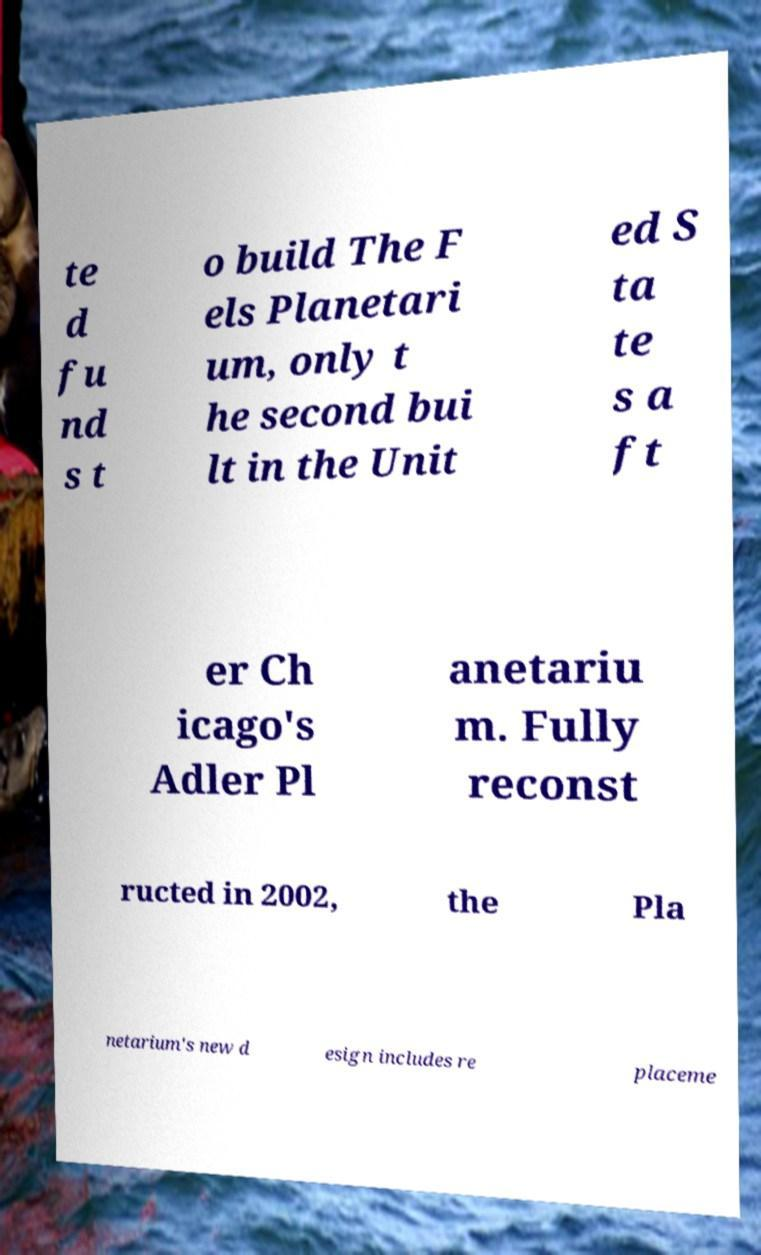Can you accurately transcribe the text from the provided image for me? te d fu nd s t o build The F els Planetari um, only t he second bui lt in the Unit ed S ta te s a ft er Ch icago's Adler Pl anetariu m. Fully reconst ructed in 2002, the Pla netarium's new d esign includes re placeme 